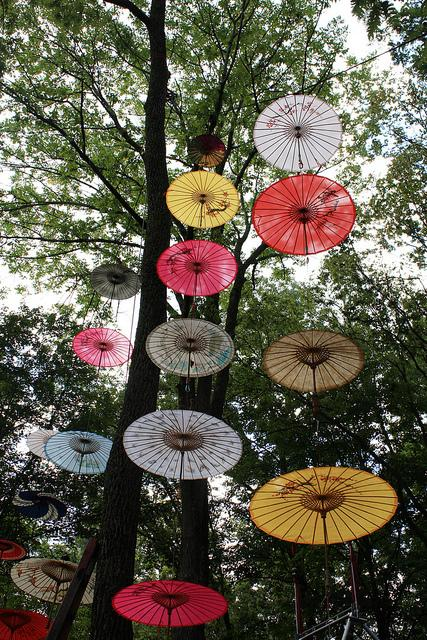What is near the colorful items? Please explain your reasoning. tree. The umbrellas are tied to trees. 